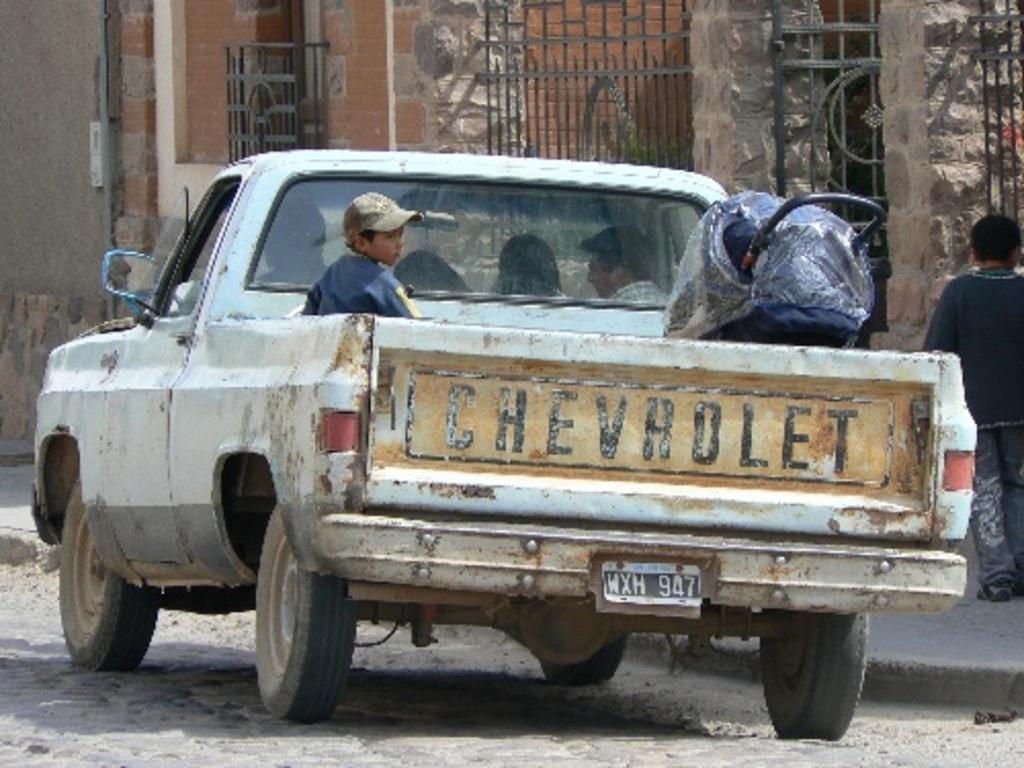Could you give a brief overview of what you see in this image? This is an outside view. In the middle of the image there is a truck. In the truck few people are sitting and there is a luggage bag. On the right side one person is walking on the footpath. In the background there is a wall and railings. 